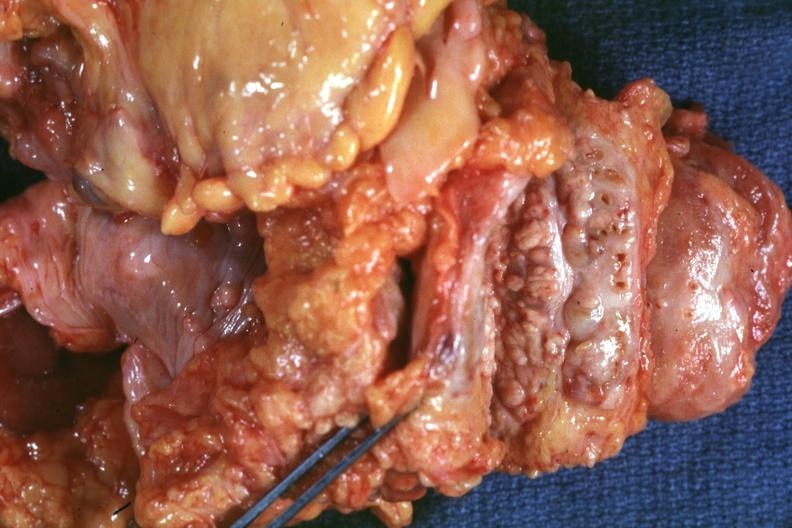what photographed close-up showing nodular parenchyma and dense intervening tumor tissue very good?
Answer the question using a single word or phrase. Bread-loaf slices into prostate gland 